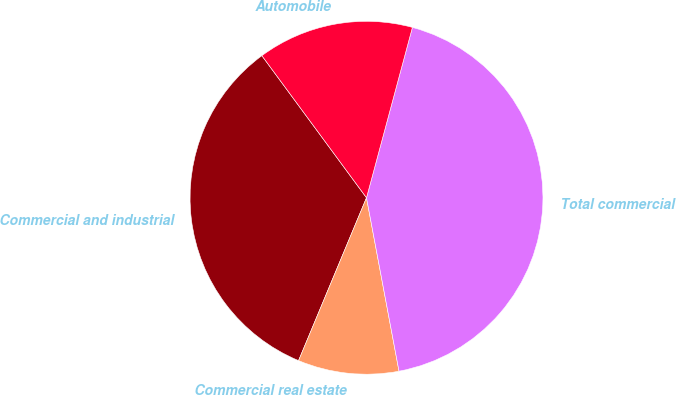<chart> <loc_0><loc_0><loc_500><loc_500><pie_chart><fcel>Commercial and industrial<fcel>Commercial real estate<fcel>Total commercial<fcel>Automobile<nl><fcel>33.61%<fcel>9.24%<fcel>42.86%<fcel>14.29%<nl></chart> 